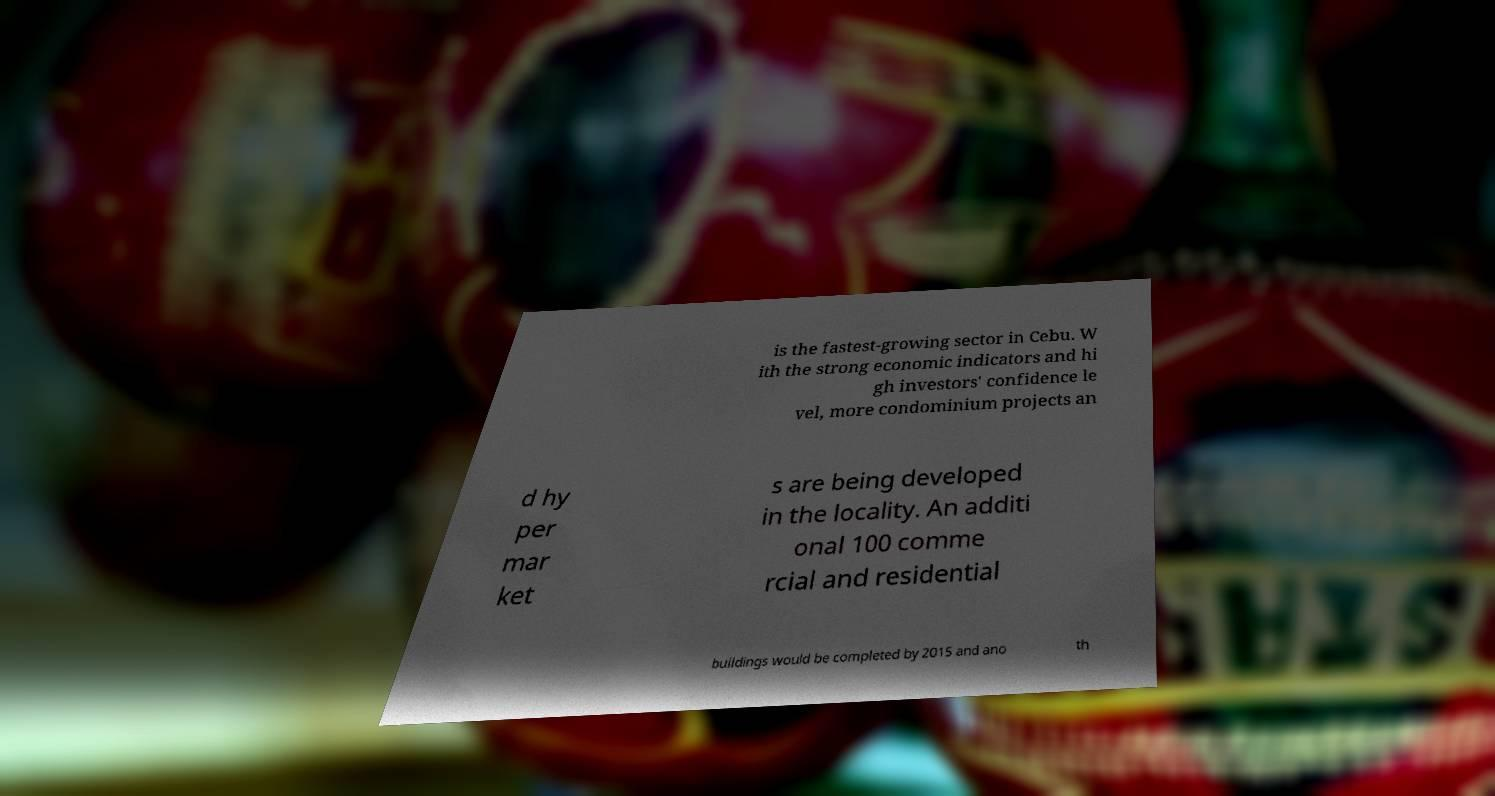For documentation purposes, I need the text within this image transcribed. Could you provide that? is the fastest-growing sector in Cebu. W ith the strong economic indicators and hi gh investors' confidence le vel, more condominium projects an d hy per mar ket s are being developed in the locality. An additi onal 100 comme rcial and residential buildings would be completed by 2015 and ano th 